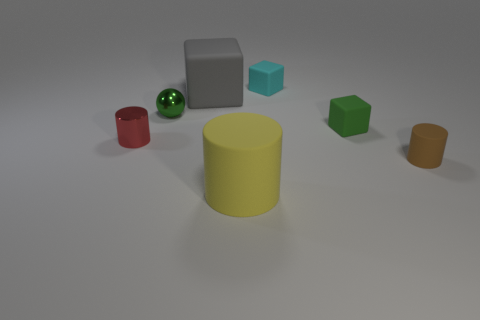How many other objects are there of the same color as the tiny sphere?
Provide a succinct answer. 1. There is a cylinder that is to the left of the big yellow matte object; is its size the same as the rubber block that is right of the tiny cyan cube?
Make the answer very short. Yes. Are there an equal number of small red cylinders to the right of the gray object and green metal objects right of the tiny rubber cylinder?
Your response must be concise. Yes. Is there any other thing that is made of the same material as the red object?
Keep it short and to the point. Yes. There is a yellow object; is its size the same as the green thing on the left side of the big matte cube?
Provide a succinct answer. No. The large object in front of the tiny cylinder that is left of the big yellow cylinder is made of what material?
Your answer should be very brief. Rubber. Are there an equal number of red shiny cylinders that are behind the large gray matte cube and large shiny blocks?
Your answer should be very brief. Yes. There is a object that is both to the right of the yellow object and in front of the red thing; how big is it?
Ensure brevity in your answer.  Small. What color is the cylinder that is on the left side of the matte cylinder that is to the left of the tiny green rubber object?
Make the answer very short. Red. How many green things are either small metal cylinders or small shiny objects?
Offer a very short reply. 1. 